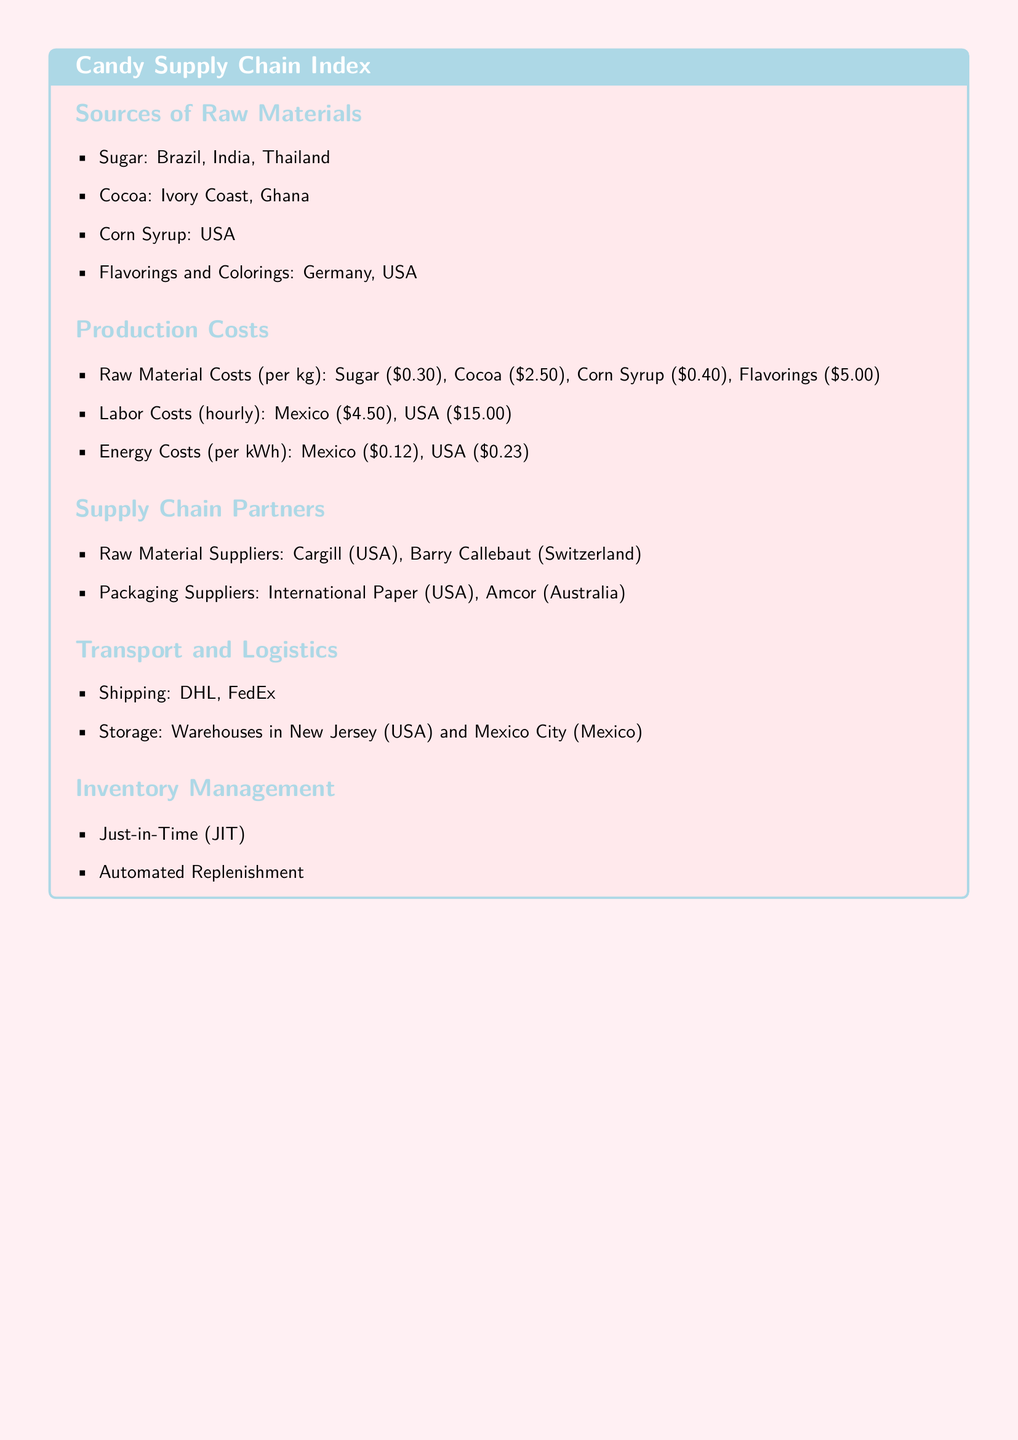What are the sources of sugar? The sources of sugar listed in the document are Brazil, India, and Thailand.
Answer: Brazil, India, Thailand What is the cost of cocoa per kg? The document states that the cost of cocoa is $2.50 per kg.
Answer: $2.50 Who are the raw material suppliers mentioned? The document mentions Cargill (USA) and Barry Callebaut (Switzerland) as raw material suppliers.
Answer: Cargill, Barry Callebaut What is the hourly labor cost in the USA? The document specifies the hourly labor cost in the USA as $15.00.
Answer: $15.00 Where are the warehouses located? According to the document, warehouses are located in New Jersey (USA) and Mexico City (Mexico).
Answer: New Jersey, Mexico City Which inventory management method is listed? The document indicates that Just-in-Time (JIT) is an inventory management method used.
Answer: Just-in-Time What is the color used for section titles? The section titles in the document are colored candy blue.
Answer: candy blue What type of document is this? This document is an index focused on the candy supply chain.
Answer: Index 